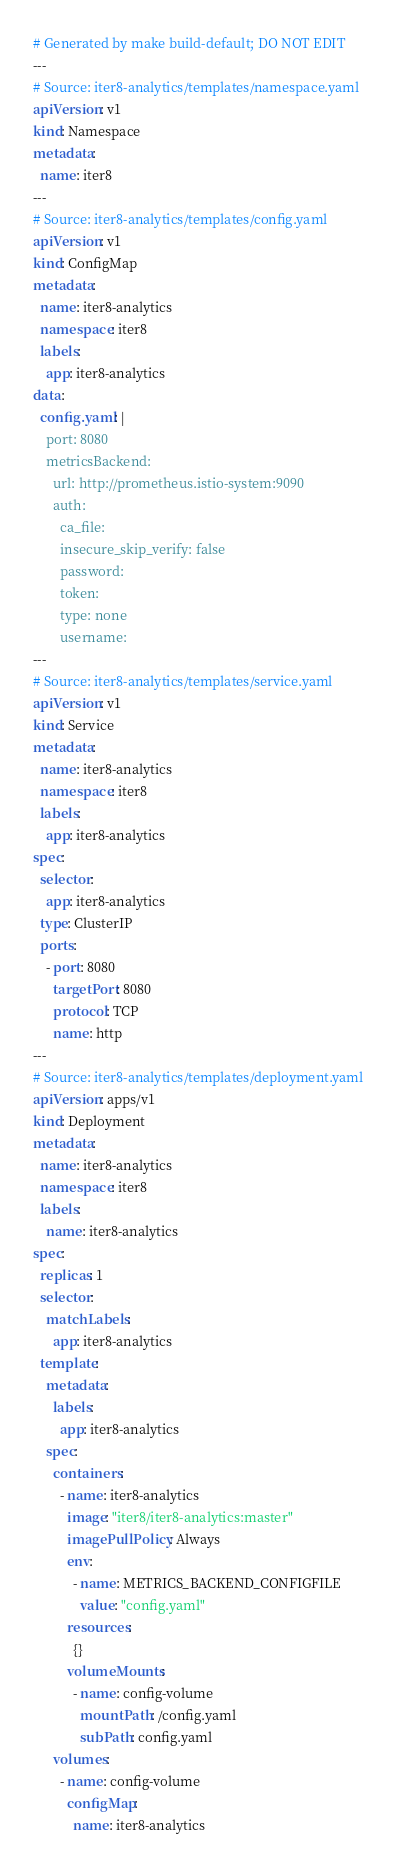Convert code to text. <code><loc_0><loc_0><loc_500><loc_500><_YAML_># Generated by make build-default; DO NOT EDIT
---
# Source: iter8-analytics/templates/namespace.yaml
apiVersion: v1
kind: Namespace
metadata:
  name: iter8
---
# Source: iter8-analytics/templates/config.yaml
apiVersion: v1
kind: ConfigMap
metadata:
  name: iter8-analytics
  namespace: iter8
  labels:
    app: iter8-analytics
data: 
  config.yaml: |
    port: 8080
    metricsBackend:
      url: http://prometheus.istio-system:9090
      auth:
        ca_file: 
        insecure_skip_verify: false
        password: 
        token: 
        type: none
        username:
---
# Source: iter8-analytics/templates/service.yaml
apiVersion: v1
kind: Service
metadata:
  name: iter8-analytics
  namespace: iter8
  labels:
    app: iter8-analytics
spec:
  selector:
    app: iter8-analytics
  type: ClusterIP
  ports:
    - port: 8080
      targetPort: 8080
      protocol: TCP
      name: http
---
# Source: iter8-analytics/templates/deployment.yaml
apiVersion: apps/v1
kind: Deployment
metadata:
  name: iter8-analytics
  namespace: iter8
  labels:
    name: iter8-analytics
spec:
  replicas: 1
  selector:
    matchLabels:
      app: iter8-analytics
  template:
    metadata:
      labels:
        app: iter8-analytics
    spec:
      containers:
        - name: iter8-analytics
          image: "iter8/iter8-analytics:master"
          imagePullPolicy: Always
          env:
            - name: METRICS_BACKEND_CONFIGFILE
              value: "config.yaml"
          resources:
            {}
          volumeMounts:
            - name: config-volume
              mountPath: /config.yaml
              subPath: config.yaml
      volumes:
        - name: config-volume
          configMap: 
            name: iter8-analytics
</code> 